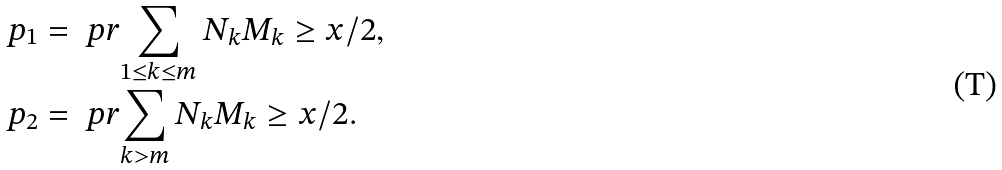<formula> <loc_0><loc_0><loc_500><loc_500>p _ { 1 } & = \ p r { \sum _ { 1 \leq k \leq m } N _ { k } M _ { k } \geq x / 2 } , \\ p _ { 2 } & = \ p r { \sum _ { k > m } N _ { k } M _ { k } \geq x / 2 } .</formula> 